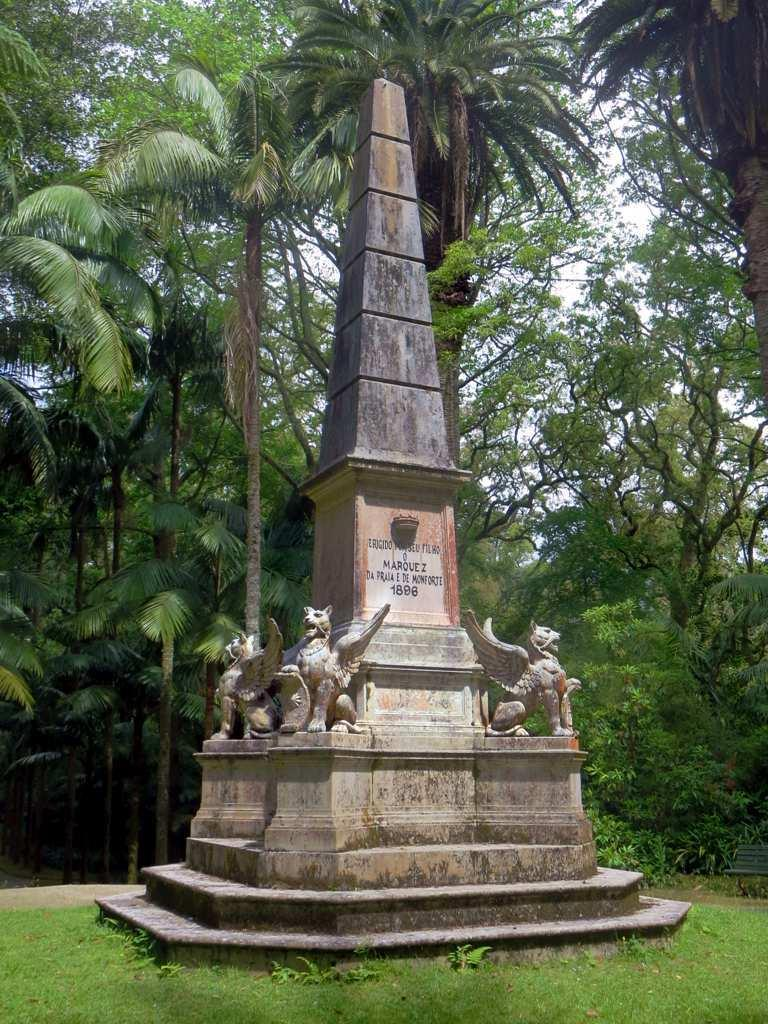What is the main subject in the center of the image? There is a statue in the center of the image. What type of surface is visible at the bottom of the image? There is grass on the surface at the bottom of the image. What can be seen in the background of the image? There are trees and the sky visible in the background of the image. What medical advice does the statue provide in the image? The statue does not provide any medical advice, as it is a non-living object and cannot speak or give advice. 